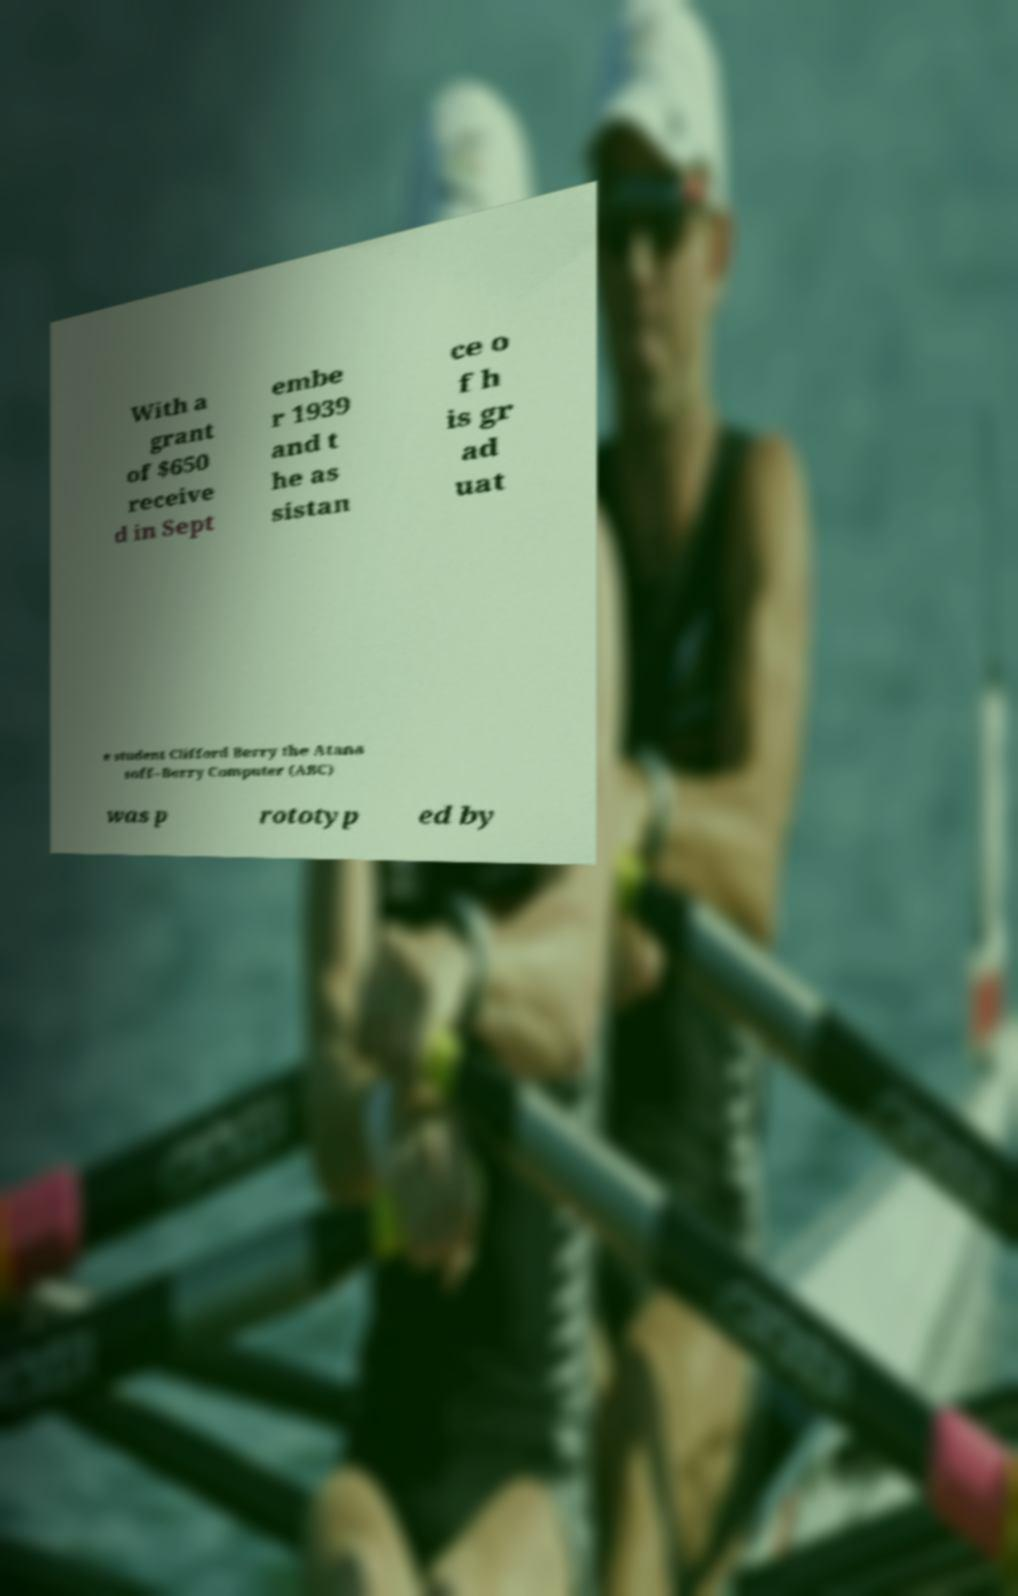There's text embedded in this image that I need extracted. Can you transcribe it verbatim? With a grant of $650 receive d in Sept embe r 1939 and t he as sistan ce o f h is gr ad uat e student Clifford Berry the Atana soff–Berry Computer (ABC) was p rototyp ed by 